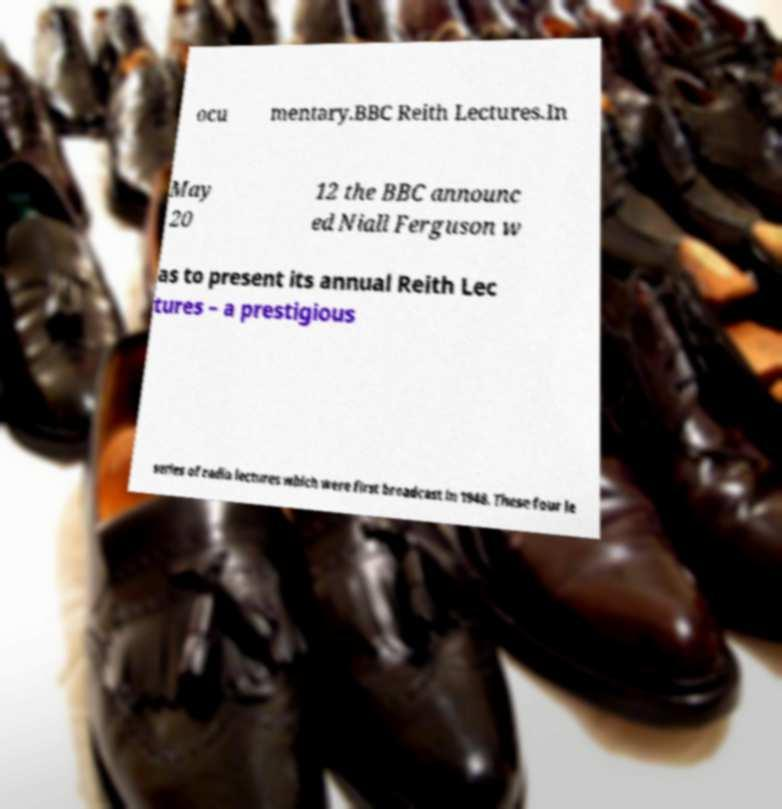There's text embedded in this image that I need extracted. Can you transcribe it verbatim? ocu mentary.BBC Reith Lectures.In May 20 12 the BBC announc ed Niall Ferguson w as to present its annual Reith Lec tures – a prestigious series of radio lectures which were first broadcast in 1948. These four le 